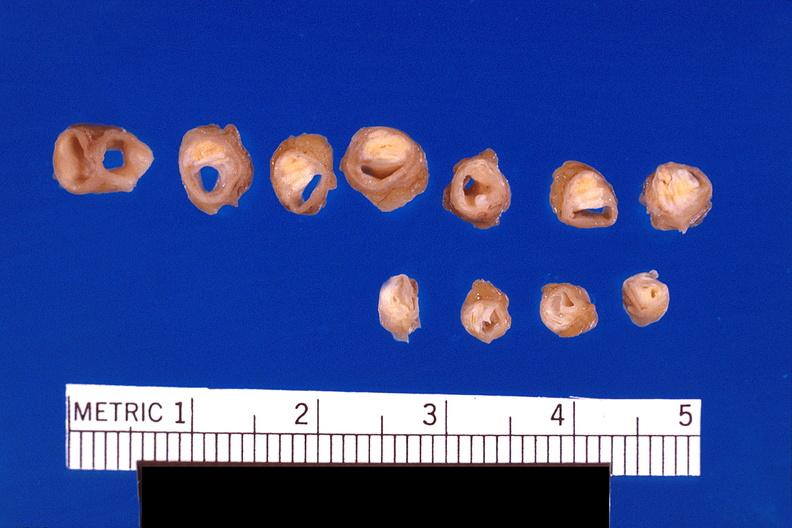where is this?
Answer the question using a single word or phrase. Vasculature 